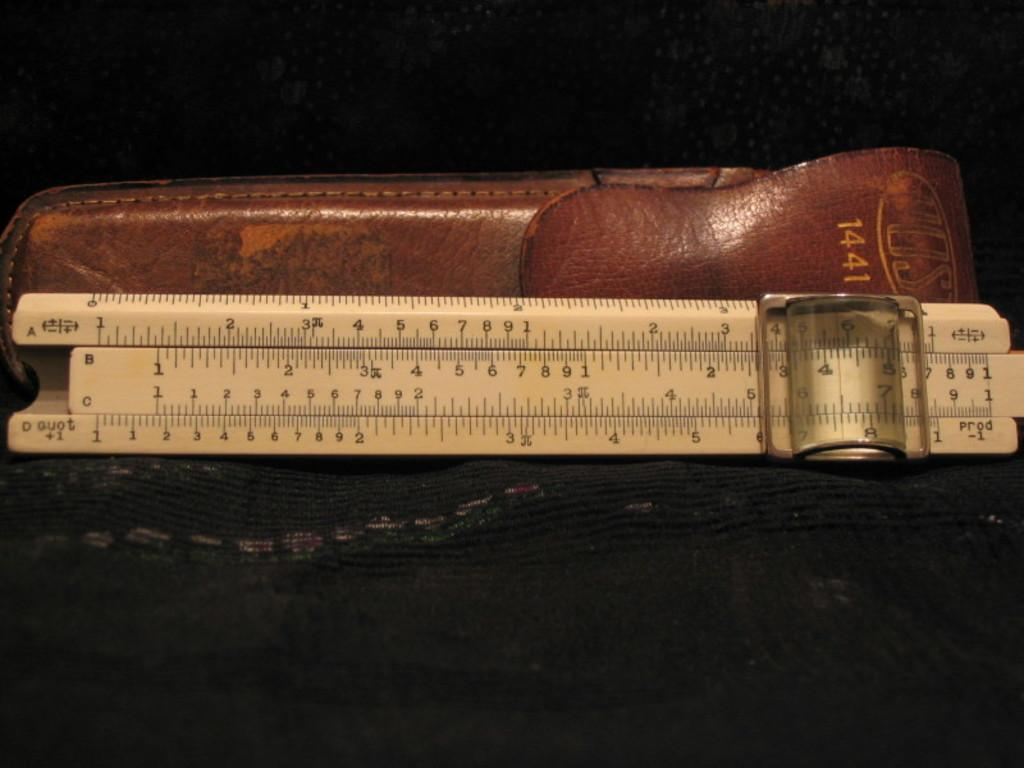What is the main object in the image? There is a slide rule in the image. What other object can be seen in the image? There is a leather object in the image. What is the color of the background in the image? The background of the image is dark. What type of skirt is visible in the image? There is no skirt present in the image. What activity is taking place in the park in the image? There is no park or any activity taking place in the image; it features a slide rule and a leather object against a dark background. 